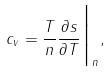Convert formula to latex. <formula><loc_0><loc_0><loc_500><loc_500>c _ { v } = \frac { T } { n } \frac { \partial s } { \partial T } { \Big | } _ { n } ,</formula> 